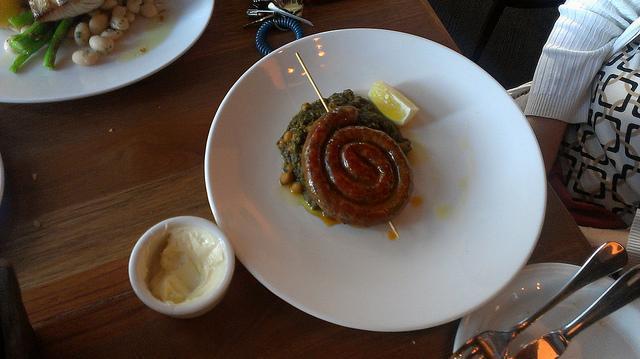What condiment is in the small white container next to the dish?
Pick the right solution, then justify: 'Answer: answer
Rationale: rationale.'
Options: Mustard, blue cheese, ranch, butter. Answer: butter.
Rationale: The butter is in the small bowl next to the plate. 